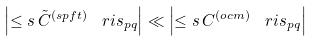<formula> <loc_0><loc_0><loc_500><loc_500>\left | \leq s \, { \tilde { C } } ^ { ( s p f t ) } \, \ r i s _ { p q } \right | \ll \left | \leq s \, C ^ { ( o c m ) } \, \ r i s _ { p q } \right |</formula> 